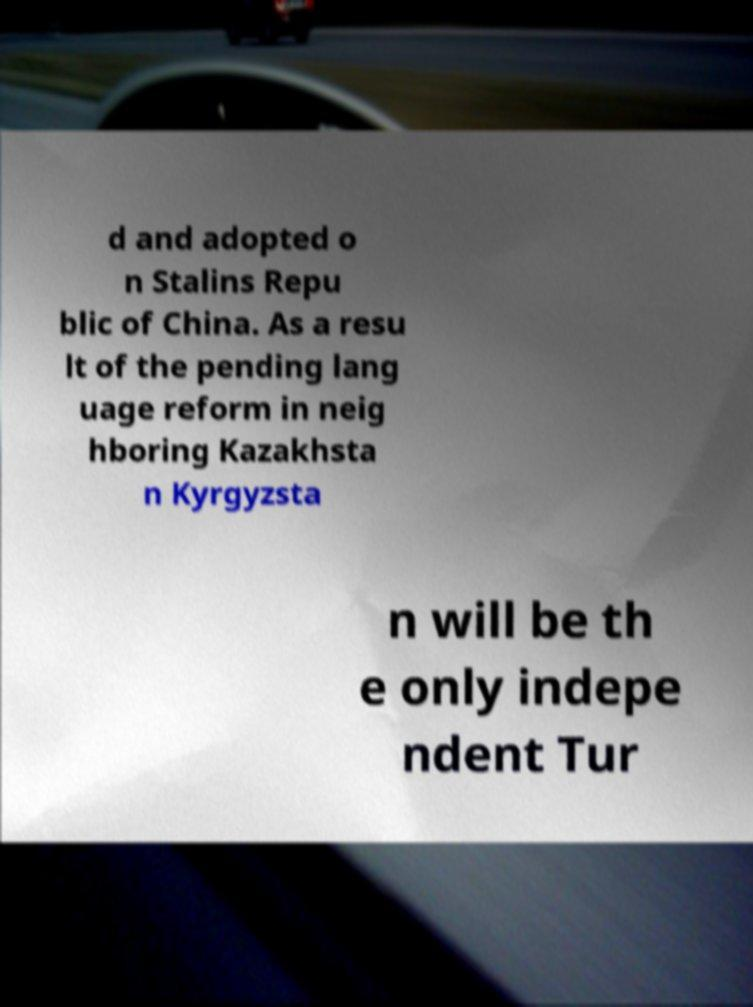Can you read and provide the text displayed in the image?This photo seems to have some interesting text. Can you extract and type it out for me? d and adopted o n Stalins Repu blic of China. As a resu lt of the pending lang uage reform in neig hboring Kazakhsta n Kyrgyzsta n will be th e only indepe ndent Tur 